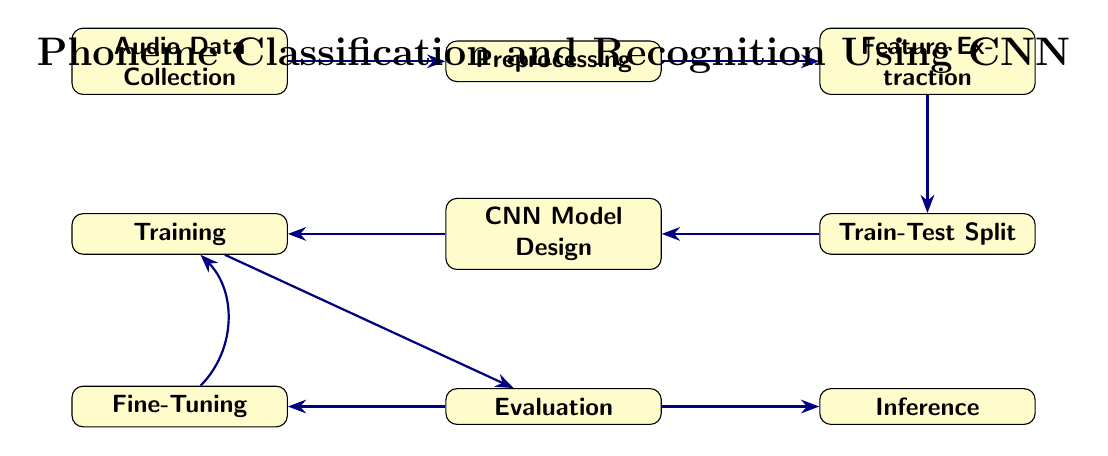What is the first step in the process? The first node in the diagram is "Audio Data Collection," which indicates the starting point of the process for phoneme classification and recognition.
Answer: Audio Data Collection How many main nodes are present in the diagram? By counting the boxes in the diagram, including all nodes, there are a total of eight distinct main nodes shown.
Answer: Eight What type of data is produced at the "Preprocessing" stage? The edge leading to the node "Feature Extraction" indicates that "Preprocessed Data" is the output of the "Preprocessing" stage.
Answer: Preprocessed Data What is the output of the "Training" node? The edge from the "Training" node points to the "Evaluation" node, indicating that the output produced is a "Trained Model."
Answer: Trained Model Which process comes after "Evaluation"? The next step after "Evaluation" is "Inference," as shown by the directed edge connecting these two nodes.
Answer: Inference What stage involves adjusting model parameters based on results? The "Fine-Tuning" node is specifically labelled to indicate that it involves refining hyperparameters, which is focused on adjusting model parameters based on evaluation results.
Answer: Fine-Tuning What are the two outputs from the "Evaluation" node? The "Evaluation" node has two edges leading away: one goes to "Final Model" and the other to "Fine-Tuning." This indicates that the outputs are "Evaluation Results" and "Final Model."
Answer: Final Model, Refinement Which node deals with splitting the dataset? The node labelled "Train-Test Split" is responsible for dividing the dataset into training and testing sets for proper evaluation of the model.
Answer: Train-Test Split What does "Feature Extraction" produce as output? The label on the edge leading from "Feature Extraction" indicates that it produces "Extracted Features" as the primary output for the subsequent stages.
Answer: Extracted Features 